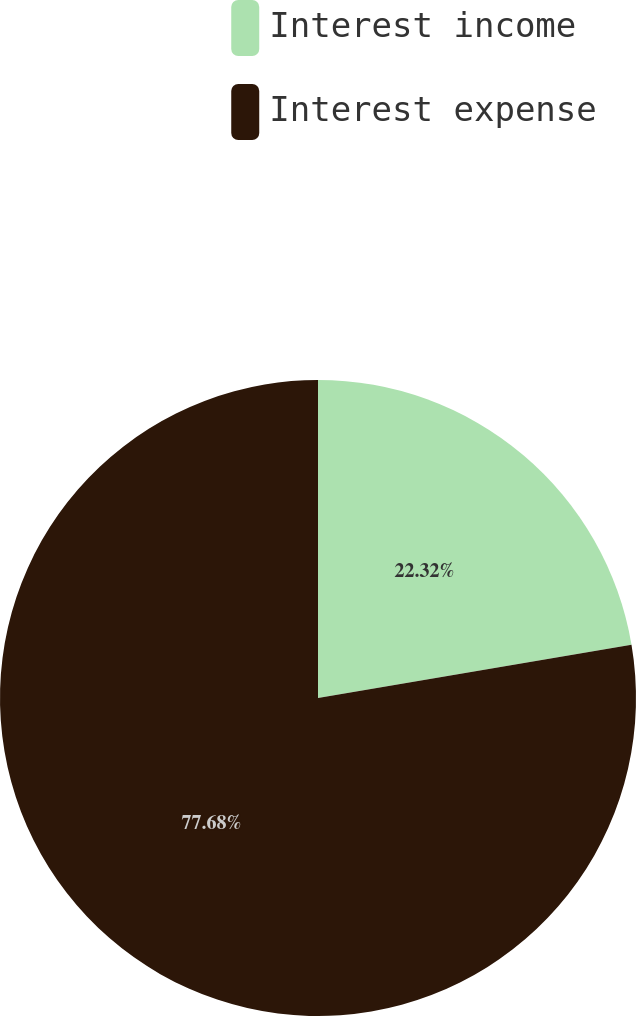Convert chart to OTSL. <chart><loc_0><loc_0><loc_500><loc_500><pie_chart><fcel>Interest income<fcel>Interest expense<nl><fcel>22.32%<fcel>77.68%<nl></chart> 